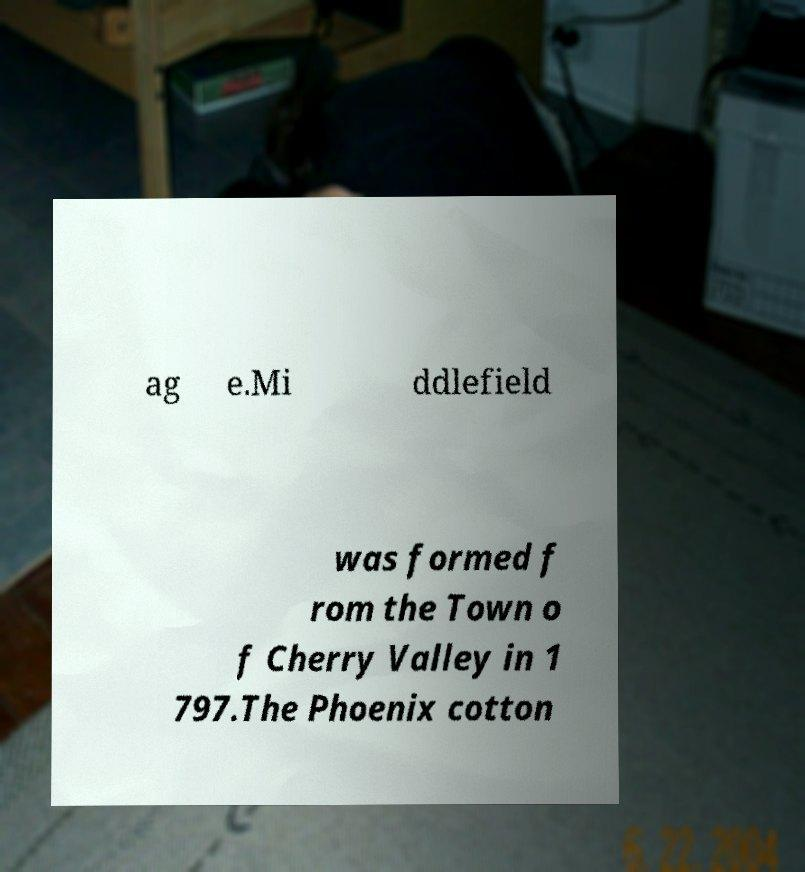Please identify and transcribe the text found in this image. ag e.Mi ddlefield was formed f rom the Town o f Cherry Valley in 1 797.The Phoenix cotton 